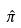Convert formula to latex. <formula><loc_0><loc_0><loc_500><loc_500>\hat { \pi }</formula> 